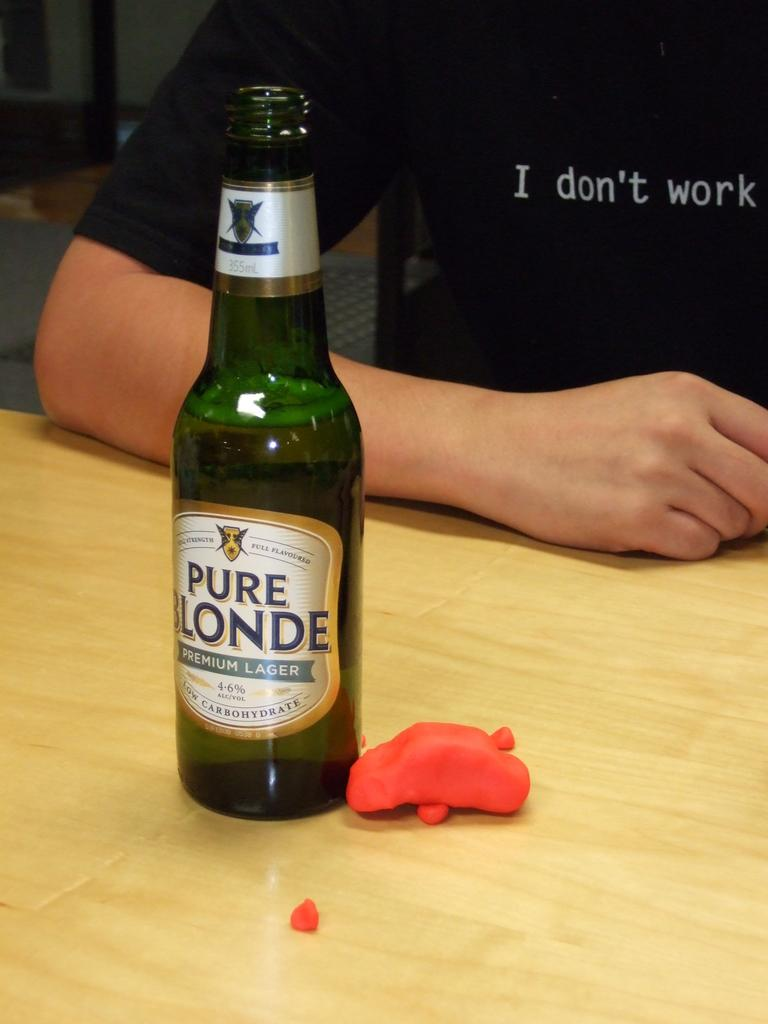<image>
Give a short and clear explanation of the subsequent image. A bottle of Pure Blonde lager is on a table with someone sitting behind. 